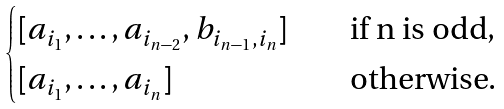<formula> <loc_0><loc_0><loc_500><loc_500>\begin{cases} [ a _ { i _ { 1 } } , \dots , a _ { i _ { n - 2 } } , b _ { i _ { n - 1 } , i _ { n } } ] & \quad \text {if n is odd} , \\ [ a _ { i _ { 1 } } , \dots , a _ { i _ { n } } ] & \quad \text {otherwise.} \\ \end{cases}</formula> 